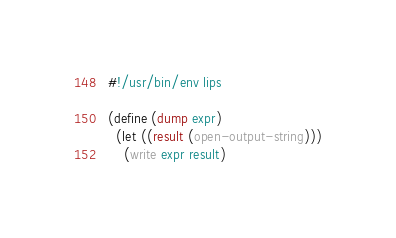Convert code to text. <code><loc_0><loc_0><loc_500><loc_500><_Scheme_>#!/usr/bin/env lips

(define (dump expr)
  (let ((result (open-output-string)))
    (write expr result)</code> 